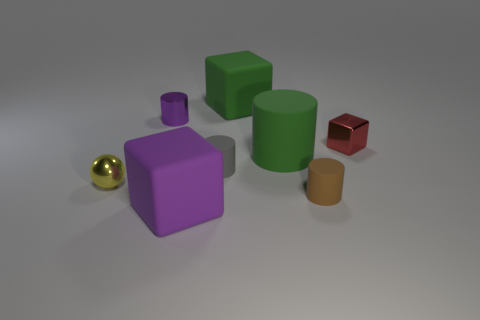Subtract all large matte blocks. How many blocks are left? 1 Add 2 gray things. How many objects exist? 10 Subtract all brown cylinders. How many cylinders are left? 3 Subtract all purple cylinders. Subtract all brown balls. How many cylinders are left? 3 Subtract all spheres. How many objects are left? 7 Subtract 0 cyan cylinders. How many objects are left? 8 Subtract all large blue metal balls. Subtract all small purple cylinders. How many objects are left? 7 Add 5 yellow objects. How many yellow objects are left? 6 Add 4 large purple matte balls. How many large purple matte balls exist? 4 